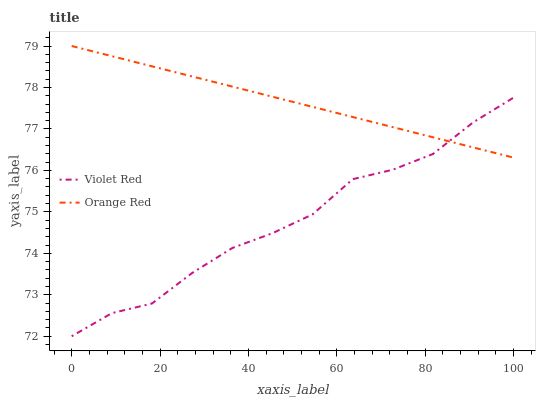Does Violet Red have the minimum area under the curve?
Answer yes or no. Yes. Does Orange Red have the maximum area under the curve?
Answer yes or no. Yes. Does Orange Red have the minimum area under the curve?
Answer yes or no. No. Is Orange Red the smoothest?
Answer yes or no. Yes. Is Violet Red the roughest?
Answer yes or no. Yes. Is Orange Red the roughest?
Answer yes or no. No. Does Violet Red have the lowest value?
Answer yes or no. Yes. Does Orange Red have the lowest value?
Answer yes or no. No. Does Orange Red have the highest value?
Answer yes or no. Yes. Does Violet Red intersect Orange Red?
Answer yes or no. Yes. Is Violet Red less than Orange Red?
Answer yes or no. No. Is Violet Red greater than Orange Red?
Answer yes or no. No. 